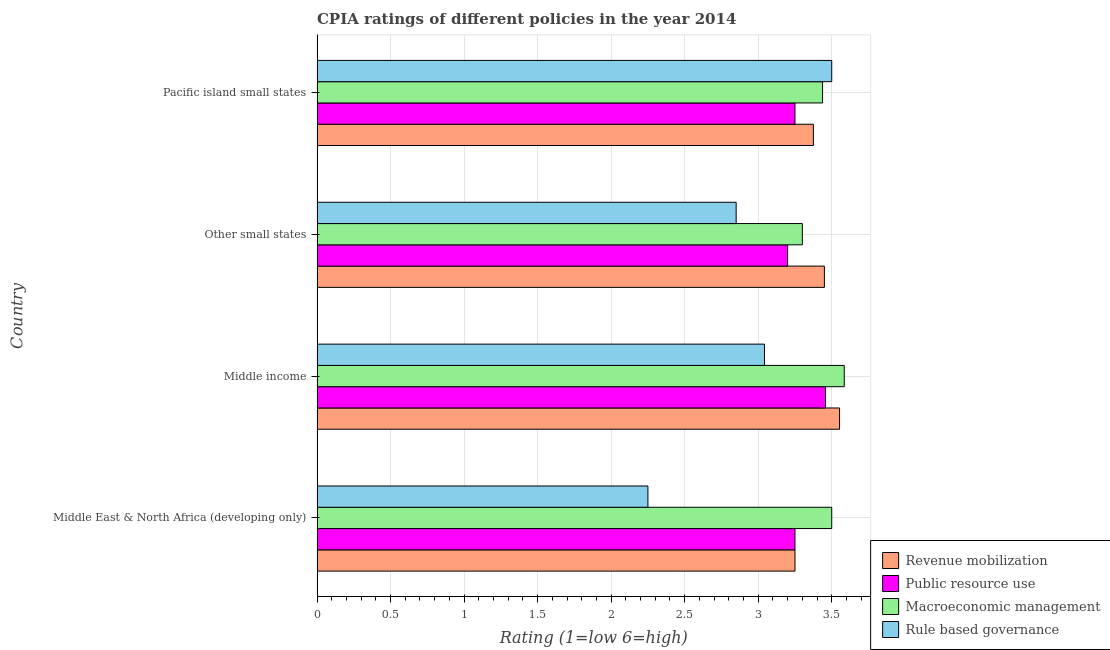How many groups of bars are there?
Offer a very short reply. 4. Are the number of bars per tick equal to the number of legend labels?
Provide a succinct answer. Yes. How many bars are there on the 2nd tick from the top?
Offer a terse response. 4. What is the label of the 2nd group of bars from the top?
Offer a terse response. Other small states. What is the cpia rating of rule based governance in Middle income?
Keep it short and to the point. 3.04. Across all countries, what is the maximum cpia rating of macroeconomic management?
Offer a very short reply. 3.59. Across all countries, what is the minimum cpia rating of macroeconomic management?
Your response must be concise. 3.3. In which country was the cpia rating of macroeconomic management minimum?
Offer a very short reply. Other small states. What is the total cpia rating of public resource use in the graph?
Provide a short and direct response. 13.16. What is the difference between the cpia rating of revenue mobilization in Middle income and that in Other small states?
Provide a succinct answer. 0.1. What is the difference between the cpia rating of rule based governance in Middle income and the cpia rating of public resource use in Middle East & North Africa (developing only)?
Give a very brief answer. -0.21. What is the average cpia rating of macroeconomic management per country?
Provide a succinct answer. 3.46. In how many countries, is the cpia rating of revenue mobilization greater than 1.3 ?
Your answer should be compact. 4. What is the ratio of the cpia rating of revenue mobilization in Middle income to that in Pacific island small states?
Your answer should be compact. 1.05. Is the cpia rating of revenue mobilization in Middle income less than that in Other small states?
Offer a very short reply. No. What is the difference between the highest and the second highest cpia rating of rule based governance?
Provide a succinct answer. 0.46. In how many countries, is the cpia rating of revenue mobilization greater than the average cpia rating of revenue mobilization taken over all countries?
Offer a terse response. 2. Is it the case that in every country, the sum of the cpia rating of revenue mobilization and cpia rating of rule based governance is greater than the sum of cpia rating of macroeconomic management and cpia rating of public resource use?
Provide a succinct answer. No. What does the 2nd bar from the top in Middle East & North Africa (developing only) represents?
Provide a short and direct response. Macroeconomic management. What does the 1st bar from the bottom in Middle income represents?
Your answer should be very brief. Revenue mobilization. How many bars are there?
Make the answer very short. 16. Are all the bars in the graph horizontal?
Ensure brevity in your answer.  Yes. How many countries are there in the graph?
Keep it short and to the point. 4. Does the graph contain any zero values?
Your response must be concise. No. Where does the legend appear in the graph?
Keep it short and to the point. Bottom right. How many legend labels are there?
Your answer should be compact. 4. How are the legend labels stacked?
Your response must be concise. Vertical. What is the title of the graph?
Your response must be concise. CPIA ratings of different policies in the year 2014. Does "Japan" appear as one of the legend labels in the graph?
Provide a succinct answer. No. What is the label or title of the Y-axis?
Your response must be concise. Country. What is the Rating (1=low 6=high) in Public resource use in Middle East & North Africa (developing only)?
Your response must be concise. 3.25. What is the Rating (1=low 6=high) in Rule based governance in Middle East & North Africa (developing only)?
Ensure brevity in your answer.  2.25. What is the Rating (1=low 6=high) in Revenue mobilization in Middle income?
Keep it short and to the point. 3.55. What is the Rating (1=low 6=high) in Public resource use in Middle income?
Make the answer very short. 3.46. What is the Rating (1=low 6=high) of Macroeconomic management in Middle income?
Give a very brief answer. 3.59. What is the Rating (1=low 6=high) in Rule based governance in Middle income?
Give a very brief answer. 3.04. What is the Rating (1=low 6=high) in Revenue mobilization in Other small states?
Provide a short and direct response. 3.45. What is the Rating (1=low 6=high) of Rule based governance in Other small states?
Ensure brevity in your answer.  2.85. What is the Rating (1=low 6=high) in Revenue mobilization in Pacific island small states?
Your answer should be very brief. 3.38. What is the Rating (1=low 6=high) in Public resource use in Pacific island small states?
Provide a succinct answer. 3.25. What is the Rating (1=low 6=high) of Macroeconomic management in Pacific island small states?
Your answer should be very brief. 3.44. Across all countries, what is the maximum Rating (1=low 6=high) of Revenue mobilization?
Keep it short and to the point. 3.55. Across all countries, what is the maximum Rating (1=low 6=high) in Public resource use?
Your answer should be very brief. 3.46. Across all countries, what is the maximum Rating (1=low 6=high) of Macroeconomic management?
Make the answer very short. 3.59. Across all countries, what is the minimum Rating (1=low 6=high) of Rule based governance?
Offer a very short reply. 2.25. What is the total Rating (1=low 6=high) of Revenue mobilization in the graph?
Your answer should be very brief. 13.63. What is the total Rating (1=low 6=high) of Public resource use in the graph?
Your answer should be very brief. 13.16. What is the total Rating (1=low 6=high) of Macroeconomic management in the graph?
Give a very brief answer. 13.82. What is the total Rating (1=low 6=high) in Rule based governance in the graph?
Your answer should be very brief. 11.64. What is the difference between the Rating (1=low 6=high) in Revenue mobilization in Middle East & North Africa (developing only) and that in Middle income?
Ensure brevity in your answer.  -0.3. What is the difference between the Rating (1=low 6=high) of Public resource use in Middle East & North Africa (developing only) and that in Middle income?
Ensure brevity in your answer.  -0.21. What is the difference between the Rating (1=low 6=high) of Macroeconomic management in Middle East & North Africa (developing only) and that in Middle income?
Provide a short and direct response. -0.09. What is the difference between the Rating (1=low 6=high) in Rule based governance in Middle East & North Africa (developing only) and that in Middle income?
Ensure brevity in your answer.  -0.79. What is the difference between the Rating (1=low 6=high) in Public resource use in Middle East & North Africa (developing only) and that in Other small states?
Make the answer very short. 0.05. What is the difference between the Rating (1=low 6=high) of Rule based governance in Middle East & North Africa (developing only) and that in Other small states?
Your answer should be compact. -0.6. What is the difference between the Rating (1=low 6=high) in Revenue mobilization in Middle East & North Africa (developing only) and that in Pacific island small states?
Your response must be concise. -0.12. What is the difference between the Rating (1=low 6=high) in Macroeconomic management in Middle East & North Africa (developing only) and that in Pacific island small states?
Your answer should be compact. 0.06. What is the difference between the Rating (1=low 6=high) of Rule based governance in Middle East & North Africa (developing only) and that in Pacific island small states?
Your answer should be very brief. -1.25. What is the difference between the Rating (1=low 6=high) in Revenue mobilization in Middle income and that in Other small states?
Give a very brief answer. 0.1. What is the difference between the Rating (1=low 6=high) of Public resource use in Middle income and that in Other small states?
Your answer should be very brief. 0.26. What is the difference between the Rating (1=low 6=high) of Macroeconomic management in Middle income and that in Other small states?
Ensure brevity in your answer.  0.29. What is the difference between the Rating (1=low 6=high) in Rule based governance in Middle income and that in Other small states?
Your answer should be very brief. 0.19. What is the difference between the Rating (1=low 6=high) of Revenue mobilization in Middle income and that in Pacific island small states?
Offer a terse response. 0.18. What is the difference between the Rating (1=low 6=high) of Public resource use in Middle income and that in Pacific island small states?
Your response must be concise. 0.21. What is the difference between the Rating (1=low 6=high) in Macroeconomic management in Middle income and that in Pacific island small states?
Provide a succinct answer. 0.15. What is the difference between the Rating (1=low 6=high) in Rule based governance in Middle income and that in Pacific island small states?
Provide a succinct answer. -0.46. What is the difference between the Rating (1=low 6=high) in Revenue mobilization in Other small states and that in Pacific island small states?
Ensure brevity in your answer.  0.07. What is the difference between the Rating (1=low 6=high) of Public resource use in Other small states and that in Pacific island small states?
Offer a terse response. -0.05. What is the difference between the Rating (1=low 6=high) in Macroeconomic management in Other small states and that in Pacific island small states?
Your answer should be very brief. -0.14. What is the difference between the Rating (1=low 6=high) of Rule based governance in Other small states and that in Pacific island small states?
Offer a terse response. -0.65. What is the difference between the Rating (1=low 6=high) of Revenue mobilization in Middle East & North Africa (developing only) and the Rating (1=low 6=high) of Public resource use in Middle income?
Offer a terse response. -0.21. What is the difference between the Rating (1=low 6=high) of Revenue mobilization in Middle East & North Africa (developing only) and the Rating (1=low 6=high) of Macroeconomic management in Middle income?
Provide a succinct answer. -0.34. What is the difference between the Rating (1=low 6=high) in Revenue mobilization in Middle East & North Africa (developing only) and the Rating (1=low 6=high) in Rule based governance in Middle income?
Keep it short and to the point. 0.21. What is the difference between the Rating (1=low 6=high) in Public resource use in Middle East & North Africa (developing only) and the Rating (1=low 6=high) in Macroeconomic management in Middle income?
Provide a short and direct response. -0.34. What is the difference between the Rating (1=low 6=high) of Public resource use in Middle East & North Africa (developing only) and the Rating (1=low 6=high) of Rule based governance in Middle income?
Make the answer very short. 0.21. What is the difference between the Rating (1=low 6=high) in Macroeconomic management in Middle East & North Africa (developing only) and the Rating (1=low 6=high) in Rule based governance in Middle income?
Provide a short and direct response. 0.46. What is the difference between the Rating (1=low 6=high) in Revenue mobilization in Middle East & North Africa (developing only) and the Rating (1=low 6=high) in Public resource use in Other small states?
Offer a terse response. 0.05. What is the difference between the Rating (1=low 6=high) in Public resource use in Middle East & North Africa (developing only) and the Rating (1=low 6=high) in Macroeconomic management in Other small states?
Offer a very short reply. -0.05. What is the difference between the Rating (1=low 6=high) of Public resource use in Middle East & North Africa (developing only) and the Rating (1=low 6=high) of Rule based governance in Other small states?
Ensure brevity in your answer.  0.4. What is the difference between the Rating (1=low 6=high) of Macroeconomic management in Middle East & North Africa (developing only) and the Rating (1=low 6=high) of Rule based governance in Other small states?
Ensure brevity in your answer.  0.65. What is the difference between the Rating (1=low 6=high) of Revenue mobilization in Middle East & North Africa (developing only) and the Rating (1=low 6=high) of Public resource use in Pacific island small states?
Give a very brief answer. 0. What is the difference between the Rating (1=low 6=high) of Revenue mobilization in Middle East & North Africa (developing only) and the Rating (1=low 6=high) of Macroeconomic management in Pacific island small states?
Offer a terse response. -0.19. What is the difference between the Rating (1=low 6=high) of Revenue mobilization in Middle East & North Africa (developing only) and the Rating (1=low 6=high) of Rule based governance in Pacific island small states?
Give a very brief answer. -0.25. What is the difference between the Rating (1=low 6=high) in Public resource use in Middle East & North Africa (developing only) and the Rating (1=low 6=high) in Macroeconomic management in Pacific island small states?
Make the answer very short. -0.19. What is the difference between the Rating (1=low 6=high) in Public resource use in Middle East & North Africa (developing only) and the Rating (1=low 6=high) in Rule based governance in Pacific island small states?
Your response must be concise. -0.25. What is the difference between the Rating (1=low 6=high) in Revenue mobilization in Middle income and the Rating (1=low 6=high) in Public resource use in Other small states?
Give a very brief answer. 0.35. What is the difference between the Rating (1=low 6=high) in Revenue mobilization in Middle income and the Rating (1=low 6=high) in Macroeconomic management in Other small states?
Give a very brief answer. 0.25. What is the difference between the Rating (1=low 6=high) in Revenue mobilization in Middle income and the Rating (1=low 6=high) in Rule based governance in Other small states?
Offer a very short reply. 0.7. What is the difference between the Rating (1=low 6=high) in Public resource use in Middle income and the Rating (1=low 6=high) in Macroeconomic management in Other small states?
Your answer should be compact. 0.16. What is the difference between the Rating (1=low 6=high) in Public resource use in Middle income and the Rating (1=low 6=high) in Rule based governance in Other small states?
Offer a very short reply. 0.61. What is the difference between the Rating (1=low 6=high) in Macroeconomic management in Middle income and the Rating (1=low 6=high) in Rule based governance in Other small states?
Provide a short and direct response. 0.74. What is the difference between the Rating (1=low 6=high) of Revenue mobilization in Middle income and the Rating (1=low 6=high) of Public resource use in Pacific island small states?
Your response must be concise. 0.3. What is the difference between the Rating (1=low 6=high) of Revenue mobilization in Middle income and the Rating (1=low 6=high) of Macroeconomic management in Pacific island small states?
Offer a very short reply. 0.12. What is the difference between the Rating (1=low 6=high) in Revenue mobilization in Middle income and the Rating (1=low 6=high) in Rule based governance in Pacific island small states?
Give a very brief answer. 0.05. What is the difference between the Rating (1=low 6=high) in Public resource use in Middle income and the Rating (1=low 6=high) in Macroeconomic management in Pacific island small states?
Give a very brief answer. 0.02. What is the difference between the Rating (1=low 6=high) in Public resource use in Middle income and the Rating (1=low 6=high) in Rule based governance in Pacific island small states?
Give a very brief answer. -0.04. What is the difference between the Rating (1=low 6=high) of Macroeconomic management in Middle income and the Rating (1=low 6=high) of Rule based governance in Pacific island small states?
Give a very brief answer. 0.09. What is the difference between the Rating (1=low 6=high) in Revenue mobilization in Other small states and the Rating (1=low 6=high) in Public resource use in Pacific island small states?
Provide a succinct answer. 0.2. What is the difference between the Rating (1=low 6=high) in Revenue mobilization in Other small states and the Rating (1=low 6=high) in Macroeconomic management in Pacific island small states?
Your answer should be compact. 0.01. What is the difference between the Rating (1=low 6=high) in Revenue mobilization in Other small states and the Rating (1=low 6=high) in Rule based governance in Pacific island small states?
Offer a terse response. -0.05. What is the difference between the Rating (1=low 6=high) of Public resource use in Other small states and the Rating (1=low 6=high) of Macroeconomic management in Pacific island small states?
Your response must be concise. -0.24. What is the difference between the Rating (1=low 6=high) in Public resource use in Other small states and the Rating (1=low 6=high) in Rule based governance in Pacific island small states?
Your answer should be compact. -0.3. What is the average Rating (1=low 6=high) in Revenue mobilization per country?
Provide a succinct answer. 3.41. What is the average Rating (1=low 6=high) of Public resource use per country?
Your answer should be very brief. 3.29. What is the average Rating (1=low 6=high) in Macroeconomic management per country?
Offer a terse response. 3.46. What is the average Rating (1=low 6=high) in Rule based governance per country?
Your response must be concise. 2.91. What is the difference between the Rating (1=low 6=high) of Revenue mobilization and Rating (1=low 6=high) of Public resource use in Middle East & North Africa (developing only)?
Provide a short and direct response. 0. What is the difference between the Rating (1=low 6=high) of Revenue mobilization and Rating (1=low 6=high) of Rule based governance in Middle East & North Africa (developing only)?
Provide a succinct answer. 1. What is the difference between the Rating (1=low 6=high) of Public resource use and Rating (1=low 6=high) of Macroeconomic management in Middle East & North Africa (developing only)?
Offer a very short reply. -0.25. What is the difference between the Rating (1=low 6=high) of Macroeconomic management and Rating (1=low 6=high) of Rule based governance in Middle East & North Africa (developing only)?
Provide a succinct answer. 1.25. What is the difference between the Rating (1=low 6=high) of Revenue mobilization and Rating (1=low 6=high) of Public resource use in Middle income?
Offer a very short reply. 0.1. What is the difference between the Rating (1=low 6=high) of Revenue mobilization and Rating (1=low 6=high) of Macroeconomic management in Middle income?
Your response must be concise. -0.03. What is the difference between the Rating (1=low 6=high) in Revenue mobilization and Rating (1=low 6=high) in Rule based governance in Middle income?
Keep it short and to the point. 0.51. What is the difference between the Rating (1=low 6=high) of Public resource use and Rating (1=low 6=high) of Macroeconomic management in Middle income?
Ensure brevity in your answer.  -0.13. What is the difference between the Rating (1=low 6=high) of Public resource use and Rating (1=low 6=high) of Rule based governance in Middle income?
Your answer should be very brief. 0.41. What is the difference between the Rating (1=low 6=high) in Macroeconomic management and Rating (1=low 6=high) in Rule based governance in Middle income?
Your response must be concise. 0.54. What is the difference between the Rating (1=low 6=high) in Revenue mobilization and Rating (1=low 6=high) in Macroeconomic management in Other small states?
Offer a terse response. 0.15. What is the difference between the Rating (1=low 6=high) of Macroeconomic management and Rating (1=low 6=high) of Rule based governance in Other small states?
Your response must be concise. 0.45. What is the difference between the Rating (1=low 6=high) in Revenue mobilization and Rating (1=low 6=high) in Macroeconomic management in Pacific island small states?
Provide a short and direct response. -0.06. What is the difference between the Rating (1=low 6=high) of Revenue mobilization and Rating (1=low 6=high) of Rule based governance in Pacific island small states?
Your answer should be very brief. -0.12. What is the difference between the Rating (1=low 6=high) of Public resource use and Rating (1=low 6=high) of Macroeconomic management in Pacific island small states?
Your response must be concise. -0.19. What is the difference between the Rating (1=low 6=high) of Public resource use and Rating (1=low 6=high) of Rule based governance in Pacific island small states?
Give a very brief answer. -0.25. What is the difference between the Rating (1=low 6=high) of Macroeconomic management and Rating (1=low 6=high) of Rule based governance in Pacific island small states?
Provide a short and direct response. -0.06. What is the ratio of the Rating (1=low 6=high) of Revenue mobilization in Middle East & North Africa (developing only) to that in Middle income?
Keep it short and to the point. 0.91. What is the ratio of the Rating (1=low 6=high) of Macroeconomic management in Middle East & North Africa (developing only) to that in Middle income?
Your answer should be compact. 0.98. What is the ratio of the Rating (1=low 6=high) of Rule based governance in Middle East & North Africa (developing only) to that in Middle income?
Your answer should be very brief. 0.74. What is the ratio of the Rating (1=low 6=high) of Revenue mobilization in Middle East & North Africa (developing only) to that in Other small states?
Ensure brevity in your answer.  0.94. What is the ratio of the Rating (1=low 6=high) of Public resource use in Middle East & North Africa (developing only) to that in Other small states?
Offer a very short reply. 1.02. What is the ratio of the Rating (1=low 6=high) of Macroeconomic management in Middle East & North Africa (developing only) to that in Other small states?
Provide a succinct answer. 1.06. What is the ratio of the Rating (1=low 6=high) in Rule based governance in Middle East & North Africa (developing only) to that in Other small states?
Keep it short and to the point. 0.79. What is the ratio of the Rating (1=low 6=high) in Public resource use in Middle East & North Africa (developing only) to that in Pacific island small states?
Provide a short and direct response. 1. What is the ratio of the Rating (1=low 6=high) of Macroeconomic management in Middle East & North Africa (developing only) to that in Pacific island small states?
Offer a terse response. 1.02. What is the ratio of the Rating (1=low 6=high) in Rule based governance in Middle East & North Africa (developing only) to that in Pacific island small states?
Ensure brevity in your answer.  0.64. What is the ratio of the Rating (1=low 6=high) in Revenue mobilization in Middle income to that in Other small states?
Provide a succinct answer. 1.03. What is the ratio of the Rating (1=low 6=high) of Public resource use in Middle income to that in Other small states?
Keep it short and to the point. 1.08. What is the ratio of the Rating (1=low 6=high) in Macroeconomic management in Middle income to that in Other small states?
Ensure brevity in your answer.  1.09. What is the ratio of the Rating (1=low 6=high) of Rule based governance in Middle income to that in Other small states?
Your answer should be very brief. 1.07. What is the ratio of the Rating (1=low 6=high) in Revenue mobilization in Middle income to that in Pacific island small states?
Give a very brief answer. 1.05. What is the ratio of the Rating (1=low 6=high) in Public resource use in Middle income to that in Pacific island small states?
Provide a succinct answer. 1.06. What is the ratio of the Rating (1=low 6=high) in Macroeconomic management in Middle income to that in Pacific island small states?
Make the answer very short. 1.04. What is the ratio of the Rating (1=low 6=high) of Rule based governance in Middle income to that in Pacific island small states?
Your answer should be very brief. 0.87. What is the ratio of the Rating (1=low 6=high) in Revenue mobilization in Other small states to that in Pacific island small states?
Your response must be concise. 1.02. What is the ratio of the Rating (1=low 6=high) of Public resource use in Other small states to that in Pacific island small states?
Provide a short and direct response. 0.98. What is the ratio of the Rating (1=low 6=high) in Rule based governance in Other small states to that in Pacific island small states?
Provide a succinct answer. 0.81. What is the difference between the highest and the second highest Rating (1=low 6=high) of Revenue mobilization?
Make the answer very short. 0.1. What is the difference between the highest and the second highest Rating (1=low 6=high) in Public resource use?
Make the answer very short. 0.21. What is the difference between the highest and the second highest Rating (1=low 6=high) of Macroeconomic management?
Provide a short and direct response. 0.09. What is the difference between the highest and the second highest Rating (1=low 6=high) of Rule based governance?
Your response must be concise. 0.46. What is the difference between the highest and the lowest Rating (1=low 6=high) of Revenue mobilization?
Keep it short and to the point. 0.3. What is the difference between the highest and the lowest Rating (1=low 6=high) in Public resource use?
Ensure brevity in your answer.  0.26. What is the difference between the highest and the lowest Rating (1=low 6=high) of Macroeconomic management?
Ensure brevity in your answer.  0.29. What is the difference between the highest and the lowest Rating (1=low 6=high) in Rule based governance?
Give a very brief answer. 1.25. 